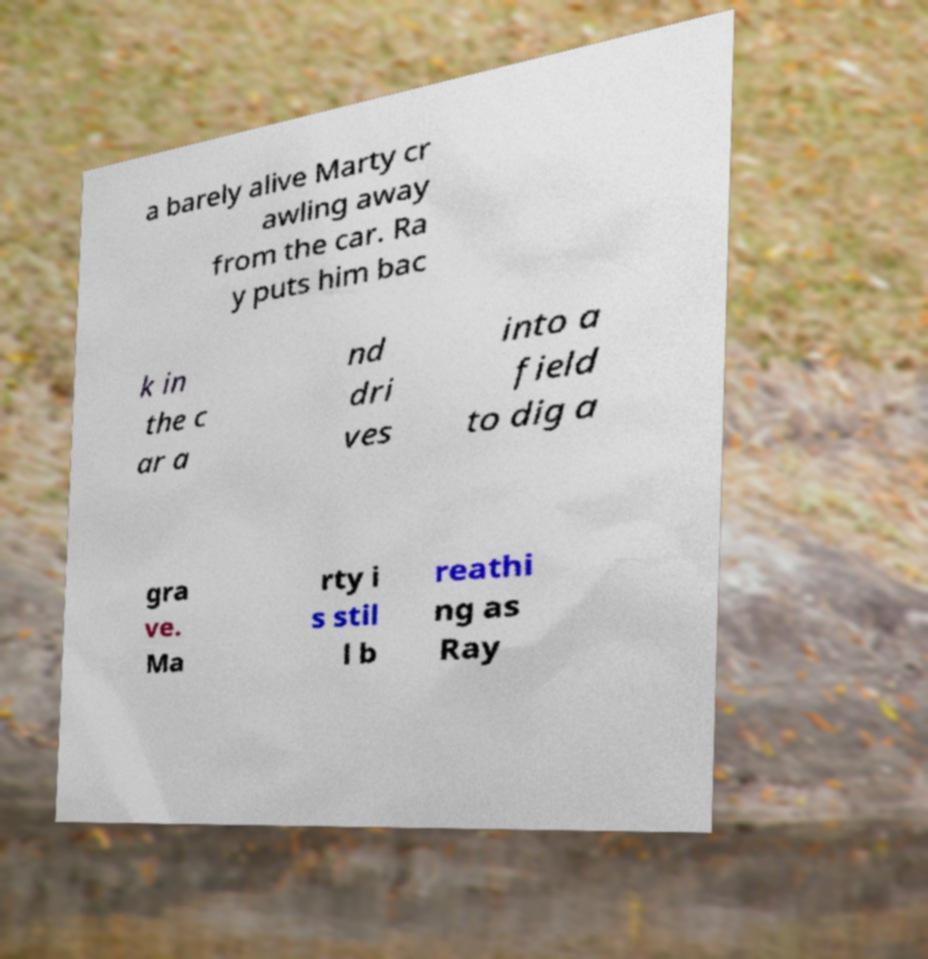Please read and relay the text visible in this image. What does it say? a barely alive Marty cr awling away from the car. Ra y puts him bac k in the c ar a nd dri ves into a field to dig a gra ve. Ma rty i s stil l b reathi ng as Ray 